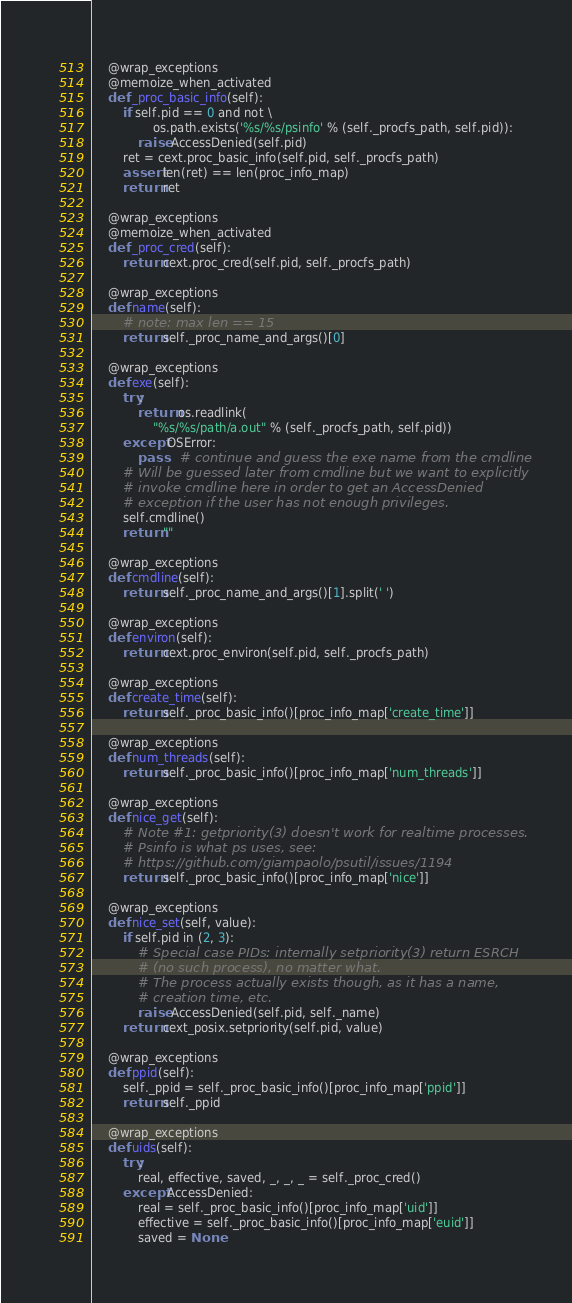Convert code to text. <code><loc_0><loc_0><loc_500><loc_500><_Python_>
    @wrap_exceptions
    @memoize_when_activated
    def _proc_basic_info(self):
        if self.pid == 0 and not \
                os.path.exists('%s/%s/psinfo' % (self._procfs_path, self.pid)):
            raise AccessDenied(self.pid)
        ret = cext.proc_basic_info(self.pid, self._procfs_path)
        assert len(ret) == len(proc_info_map)
        return ret

    @wrap_exceptions
    @memoize_when_activated
    def _proc_cred(self):
        return cext.proc_cred(self.pid, self._procfs_path)

    @wrap_exceptions
    def name(self):
        # note: max len == 15
        return self._proc_name_and_args()[0]

    @wrap_exceptions
    def exe(self):
        try:
            return os.readlink(
                "%s/%s/path/a.out" % (self._procfs_path, self.pid))
        except OSError:
            pass    # continue and guess the exe name from the cmdline
        # Will be guessed later from cmdline but we want to explicitly
        # invoke cmdline here in order to get an AccessDenied
        # exception if the user has not enough privileges.
        self.cmdline()
        return ""

    @wrap_exceptions
    def cmdline(self):
        return self._proc_name_and_args()[1].split(' ')

    @wrap_exceptions
    def environ(self):
        return cext.proc_environ(self.pid, self._procfs_path)

    @wrap_exceptions
    def create_time(self):
        return self._proc_basic_info()[proc_info_map['create_time']]

    @wrap_exceptions
    def num_threads(self):
        return self._proc_basic_info()[proc_info_map['num_threads']]

    @wrap_exceptions
    def nice_get(self):
        # Note #1: getpriority(3) doesn't work for realtime processes.
        # Psinfo is what ps uses, see:
        # https://github.com/giampaolo/psutil/issues/1194
        return self._proc_basic_info()[proc_info_map['nice']]

    @wrap_exceptions
    def nice_set(self, value):
        if self.pid in (2, 3):
            # Special case PIDs: internally setpriority(3) return ESRCH
            # (no such process), no matter what.
            # The process actually exists though, as it has a name,
            # creation time, etc.
            raise AccessDenied(self.pid, self._name)
        return cext_posix.setpriority(self.pid, value)

    @wrap_exceptions
    def ppid(self):
        self._ppid = self._proc_basic_info()[proc_info_map['ppid']]
        return self._ppid

    @wrap_exceptions
    def uids(self):
        try:
            real, effective, saved, _, _, _ = self._proc_cred()
        except AccessDenied:
            real = self._proc_basic_info()[proc_info_map['uid']]
            effective = self._proc_basic_info()[proc_info_map['euid']]
            saved = None</code> 